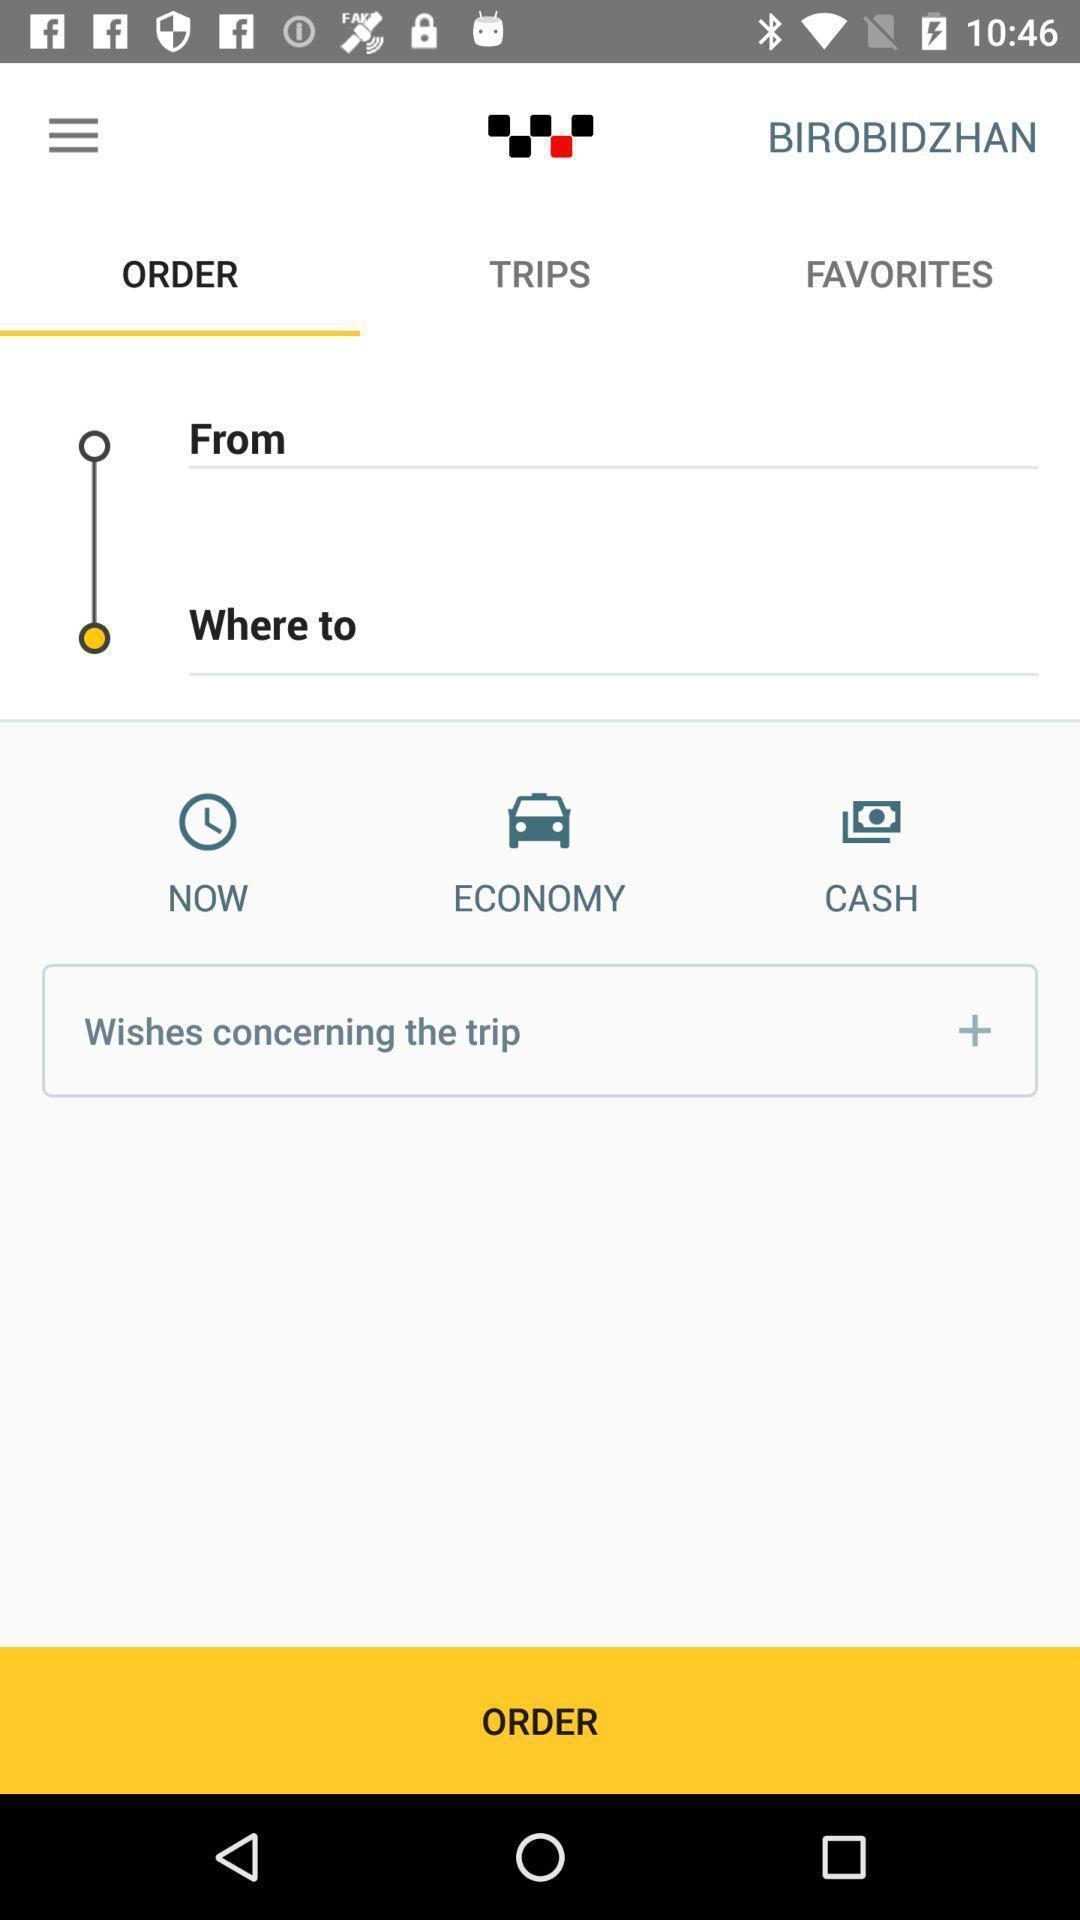Explain what's happening in this screen capture. Screen shows a order of transport. 